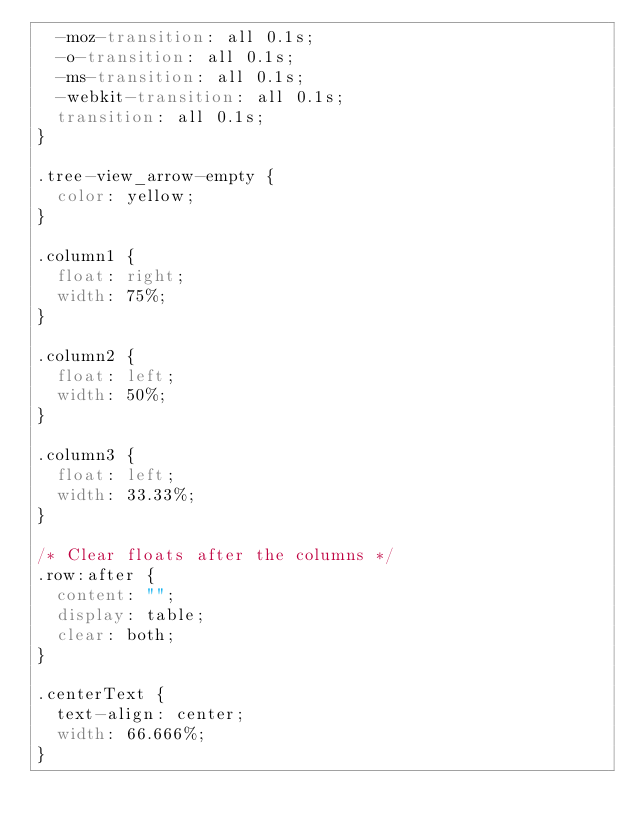<code> <loc_0><loc_0><loc_500><loc_500><_CSS_>  -moz-transition: all 0.1s;
  -o-transition: all 0.1s;
  -ms-transition: all 0.1s;
  -webkit-transition: all 0.1s;
  transition: all 0.1s;
}

.tree-view_arrow-empty {
  color: yellow;
}

.column1 {
  float: right;
  width: 75%;
}

.column2 {
  float: left;
  width: 50%;
}

.column3 {
  float: left;
  width: 33.33%;
}

/* Clear floats after the columns */
.row:after {
  content: "";
  display: table;
  clear: both;
}

.centerText {
  text-align: center;
  width: 66.666%;
}
</code> 